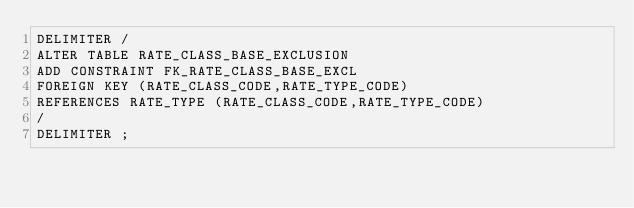Convert code to text. <code><loc_0><loc_0><loc_500><loc_500><_SQL_>DELIMITER /
ALTER TABLE RATE_CLASS_BASE_EXCLUSION 
ADD CONSTRAINT FK_RATE_CLASS_BASE_EXCL 
FOREIGN KEY (RATE_CLASS_CODE,RATE_TYPE_CODE) 
REFERENCES RATE_TYPE (RATE_CLASS_CODE,RATE_TYPE_CODE)
/
DELIMITER ;
</code> 